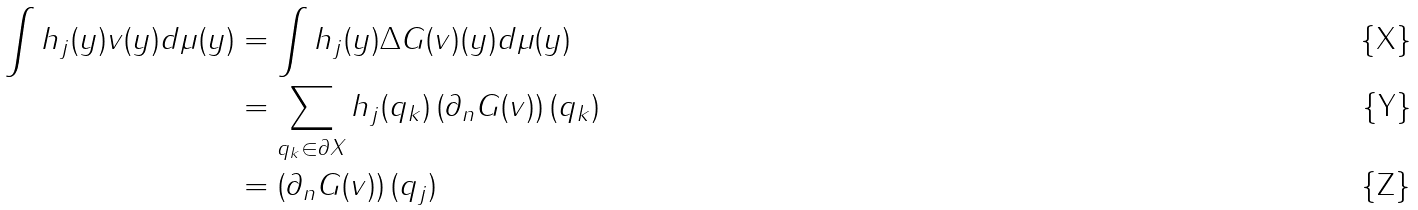<formula> <loc_0><loc_0><loc_500><loc_500>\int h _ { j } ( y ) v ( y ) d \mu ( y ) & = \int h _ { j } ( y ) \Delta G ( v ) ( y ) d \mu ( y ) \\ & = \sum _ { q _ { k } \in \partial X } h _ { j } ( q _ { k } ) \left ( \partial _ { n } G ( v ) \right ) ( q _ { k } ) \\ & = \left ( \partial _ { n } G ( v ) \right ) ( q _ { j } )</formula> 